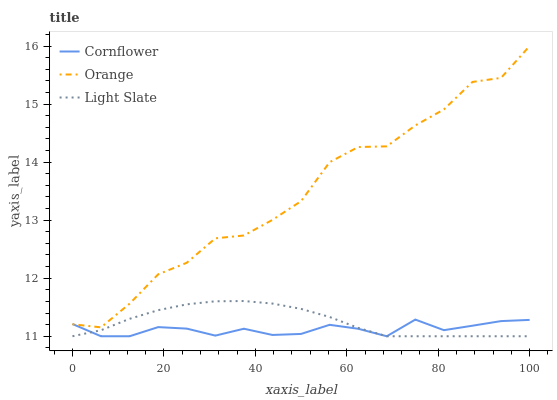Does Cornflower have the minimum area under the curve?
Answer yes or no. Yes. Does Orange have the maximum area under the curve?
Answer yes or no. Yes. Does Light Slate have the minimum area under the curve?
Answer yes or no. No. Does Light Slate have the maximum area under the curve?
Answer yes or no. No. Is Light Slate the smoothest?
Answer yes or no. Yes. Is Orange the roughest?
Answer yes or no. Yes. Is Cornflower the smoothest?
Answer yes or no. No. Is Cornflower the roughest?
Answer yes or no. No. Does Cornflower have the lowest value?
Answer yes or no. Yes. Does Orange have the highest value?
Answer yes or no. Yes. Does Light Slate have the highest value?
Answer yes or no. No. Is Light Slate less than Orange?
Answer yes or no. Yes. Is Orange greater than Light Slate?
Answer yes or no. Yes. Does Cornflower intersect Light Slate?
Answer yes or no. Yes. Is Cornflower less than Light Slate?
Answer yes or no. No. Is Cornflower greater than Light Slate?
Answer yes or no. No. Does Light Slate intersect Orange?
Answer yes or no. No. 